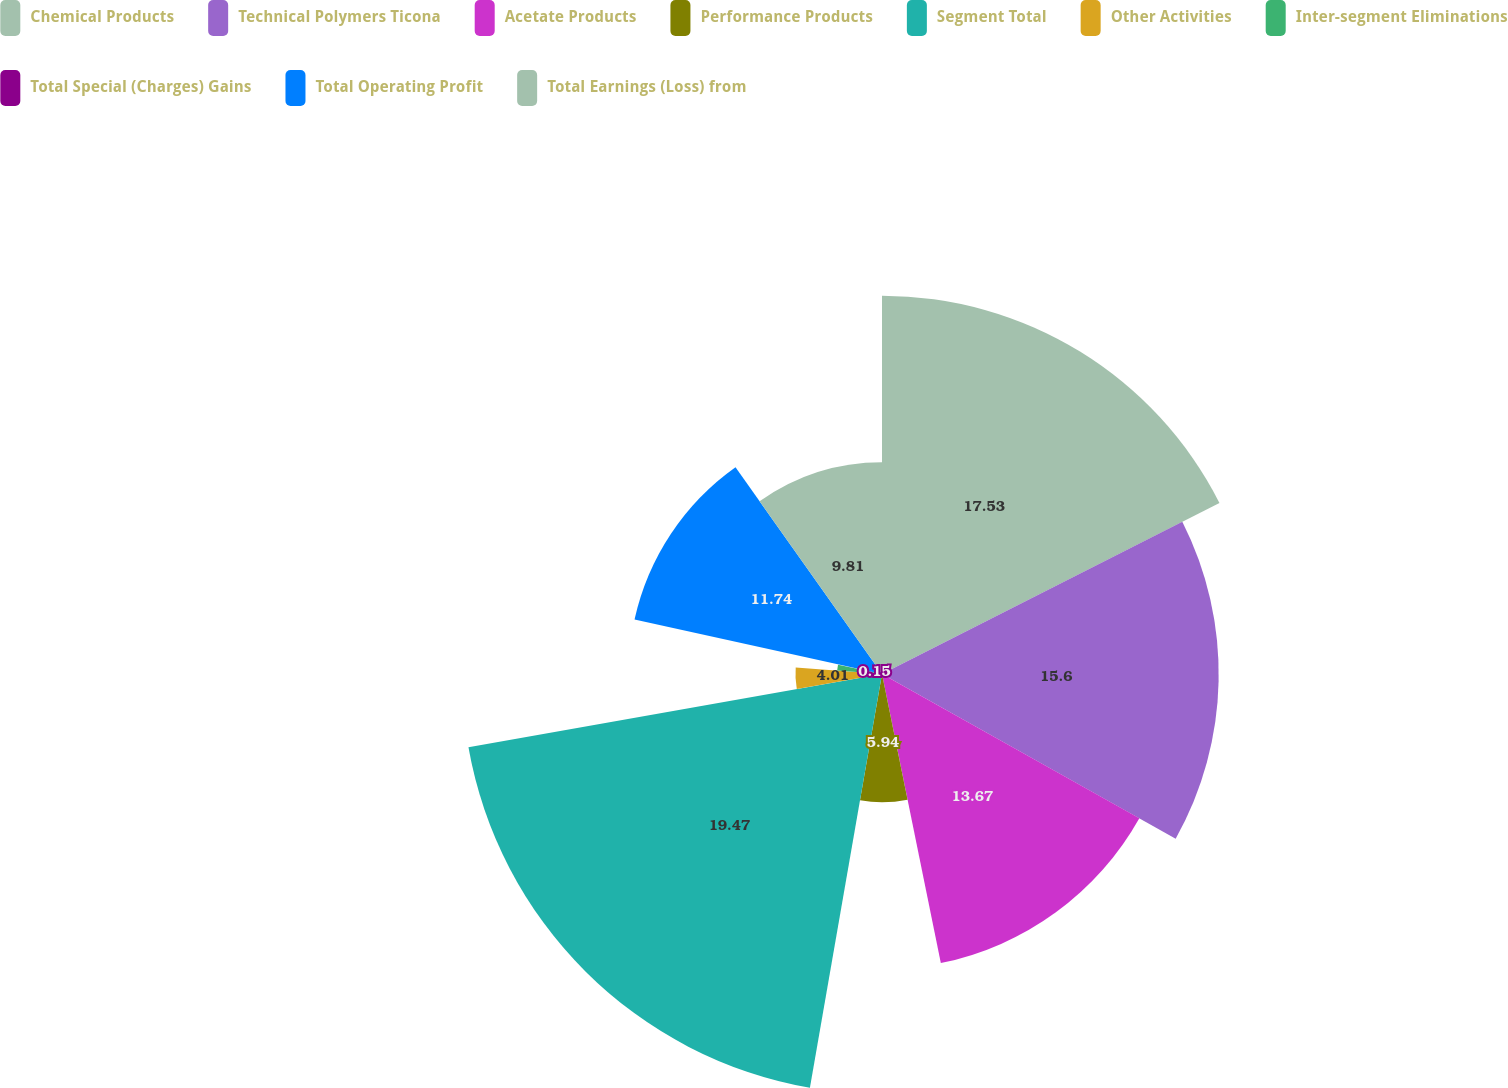<chart> <loc_0><loc_0><loc_500><loc_500><pie_chart><fcel>Chemical Products<fcel>Technical Polymers Ticona<fcel>Acetate Products<fcel>Performance Products<fcel>Segment Total<fcel>Other Activities<fcel>Inter-segment Eliminations<fcel>Total Special (Charges) Gains<fcel>Total Operating Profit<fcel>Total Earnings (Loss) from<nl><fcel>17.53%<fcel>15.6%<fcel>13.67%<fcel>5.94%<fcel>19.46%<fcel>4.01%<fcel>2.08%<fcel>0.15%<fcel>11.74%<fcel>9.81%<nl></chart> 